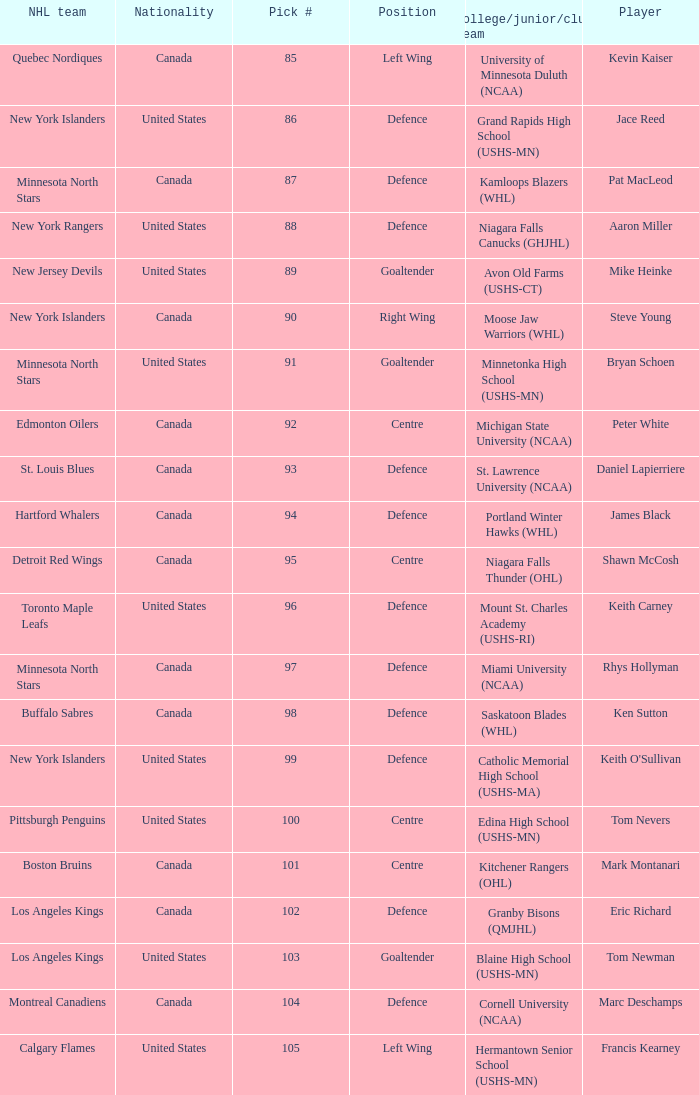What pick number was marc deschamps? 104.0. Would you mind parsing the complete table? {'header': ['NHL team', 'Nationality', 'Pick #', 'Position', 'College/junior/club team', 'Player'], 'rows': [['Quebec Nordiques', 'Canada', '85', 'Left Wing', 'University of Minnesota Duluth (NCAA)', 'Kevin Kaiser'], ['New York Islanders', 'United States', '86', 'Defence', 'Grand Rapids High School (USHS-MN)', 'Jace Reed'], ['Minnesota North Stars', 'Canada', '87', 'Defence', 'Kamloops Blazers (WHL)', 'Pat MacLeod'], ['New York Rangers', 'United States', '88', 'Defence', 'Niagara Falls Canucks (GHJHL)', 'Aaron Miller'], ['New Jersey Devils', 'United States', '89', 'Goaltender', 'Avon Old Farms (USHS-CT)', 'Mike Heinke'], ['New York Islanders', 'Canada', '90', 'Right Wing', 'Moose Jaw Warriors (WHL)', 'Steve Young'], ['Minnesota North Stars', 'United States', '91', 'Goaltender', 'Minnetonka High School (USHS-MN)', 'Bryan Schoen'], ['Edmonton Oilers', 'Canada', '92', 'Centre', 'Michigan State University (NCAA)', 'Peter White'], ['St. Louis Blues', 'Canada', '93', 'Defence', 'St. Lawrence University (NCAA)', 'Daniel Lapierriere'], ['Hartford Whalers', 'Canada', '94', 'Defence', 'Portland Winter Hawks (WHL)', 'James Black'], ['Detroit Red Wings', 'Canada', '95', 'Centre', 'Niagara Falls Thunder (OHL)', 'Shawn McCosh'], ['Toronto Maple Leafs', 'United States', '96', 'Defence', 'Mount St. Charles Academy (USHS-RI)', 'Keith Carney'], ['Minnesota North Stars', 'Canada', '97', 'Defence', 'Miami University (NCAA)', 'Rhys Hollyman'], ['Buffalo Sabres', 'Canada', '98', 'Defence', 'Saskatoon Blades (WHL)', 'Ken Sutton'], ['New York Islanders', 'United States', '99', 'Defence', 'Catholic Memorial High School (USHS-MA)', "Keith O'Sullivan"], ['Pittsburgh Penguins', 'United States', '100', 'Centre', 'Edina High School (USHS-MN)', 'Tom Nevers'], ['Boston Bruins', 'Canada', '101', 'Centre', 'Kitchener Rangers (OHL)', 'Mark Montanari'], ['Los Angeles Kings', 'Canada', '102', 'Defence', 'Granby Bisons (QMJHL)', 'Eric Richard'], ['Los Angeles Kings', 'United States', '103', 'Goaltender', 'Blaine High School (USHS-MN)', 'Tom Newman'], ['Montreal Canadiens', 'Canada', '104', 'Defence', 'Cornell University (NCAA)', 'Marc Deschamps'], ['Calgary Flames', 'United States', '105', 'Left Wing', 'Hermantown Senior School (USHS-MN)', 'Francis Kearney']]} 